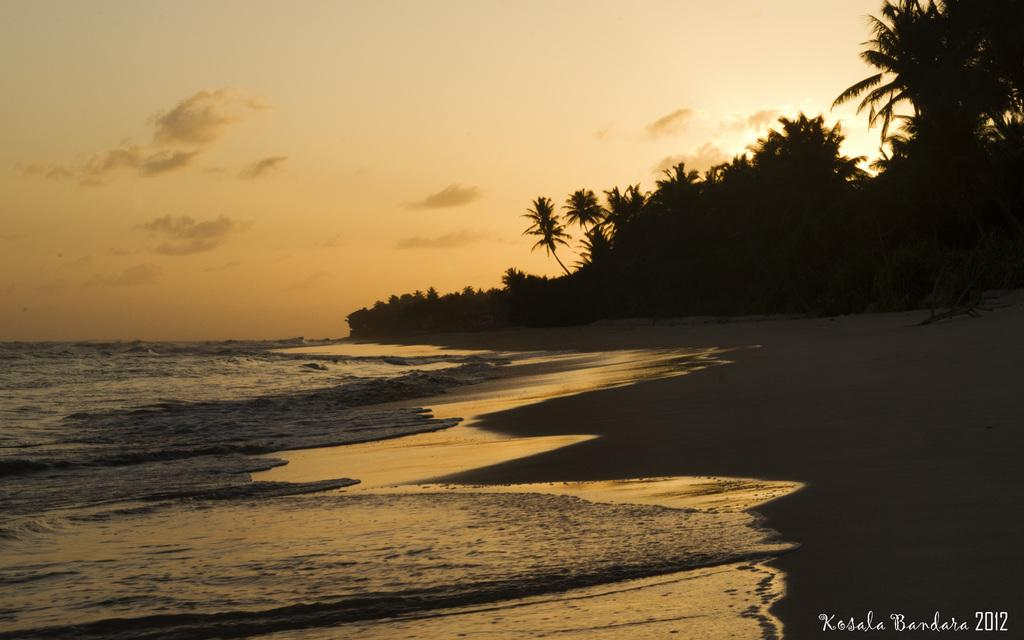What type of natural environment is depicted in the image? The image features a sea and a seashore. What type of vegetation can be seen in the image? There are trees in the image. What is visible in the sky in the image? The sky is visible in the image, and there are clouds present. What decision did the friend make in the image? There is no friend or decision-making process depicted in the image. 